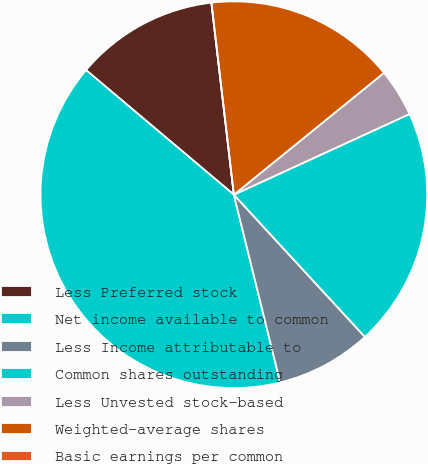<chart> <loc_0><loc_0><loc_500><loc_500><pie_chart><fcel>Less Preferred stock<fcel>Net income available to common<fcel>Less Income attributable to<fcel>Common shares outstanding<fcel>Less Unvested stock-based<fcel>Weighted-average shares<fcel>Basic earnings per common<nl><fcel>12.0%<fcel>40.0%<fcel>8.0%<fcel>20.0%<fcel>4.0%<fcel>16.0%<fcel>0.0%<nl></chart> 